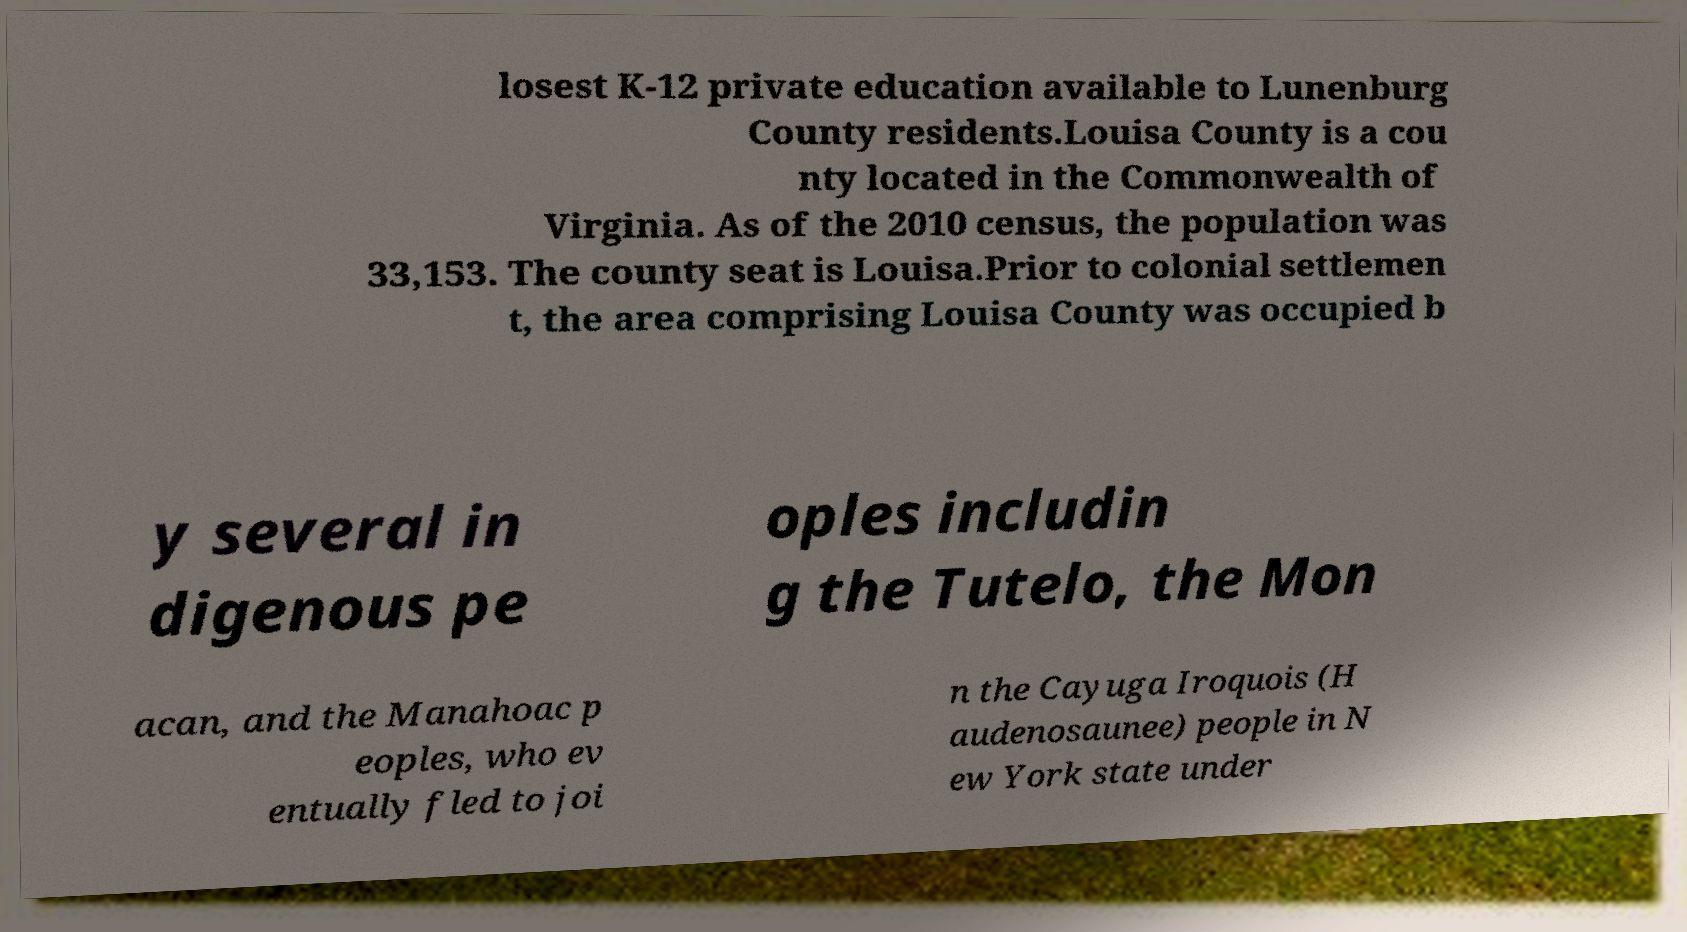Can you read and provide the text displayed in the image?This photo seems to have some interesting text. Can you extract and type it out for me? losest K-12 private education available to Lunenburg County residents.Louisa County is a cou nty located in the Commonwealth of Virginia. As of the 2010 census, the population was 33,153. The county seat is Louisa.Prior to colonial settlemen t, the area comprising Louisa County was occupied b y several in digenous pe oples includin g the Tutelo, the Mon acan, and the Manahoac p eoples, who ev entually fled to joi n the Cayuga Iroquois (H audenosaunee) people in N ew York state under 